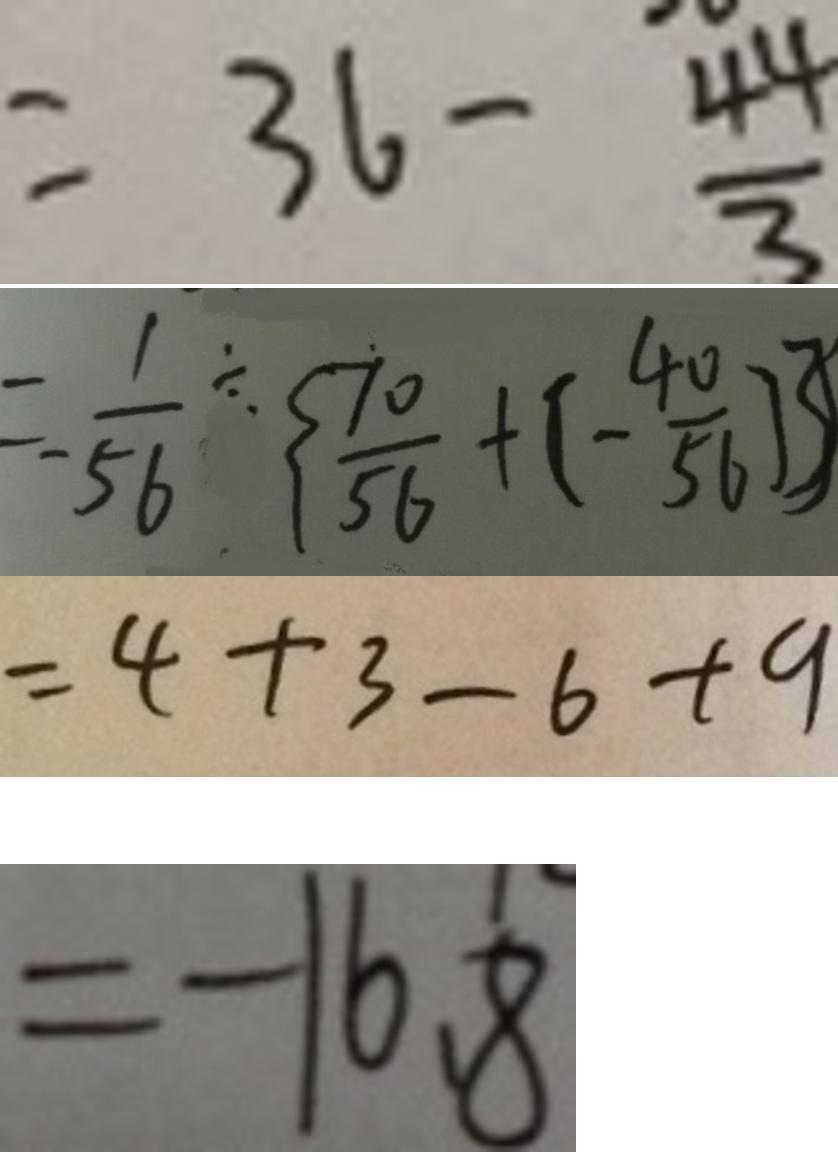<formula> <loc_0><loc_0><loc_500><loc_500>= 3 6 - \frac { 4 4 } { 3 } 
 = - \frac { 1 } { 5 6 } \div \{ \frac { 7 0 } { 5 6 } + ( - \frac { 4 0 } { 5 6 } ) \} 
 = 4 + 3 - 6 + 9 
 = - 1 6 . 8</formula> 